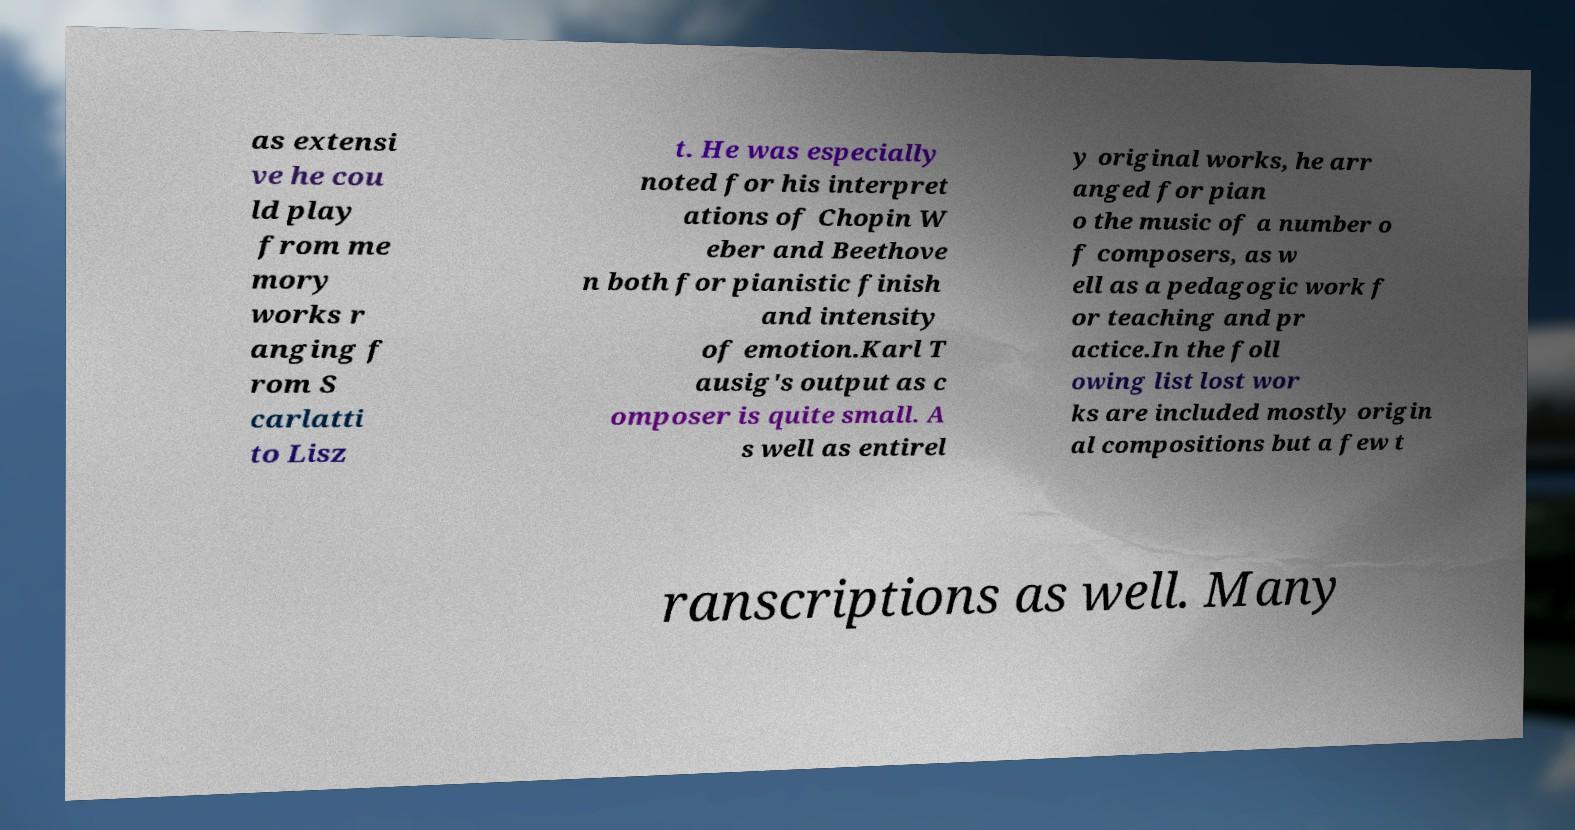I need the written content from this picture converted into text. Can you do that? as extensi ve he cou ld play from me mory works r anging f rom S carlatti to Lisz t. He was especially noted for his interpret ations of Chopin W eber and Beethove n both for pianistic finish and intensity of emotion.Karl T ausig's output as c omposer is quite small. A s well as entirel y original works, he arr anged for pian o the music of a number o f composers, as w ell as a pedagogic work f or teaching and pr actice.In the foll owing list lost wor ks are included mostly origin al compositions but a few t ranscriptions as well. Many 